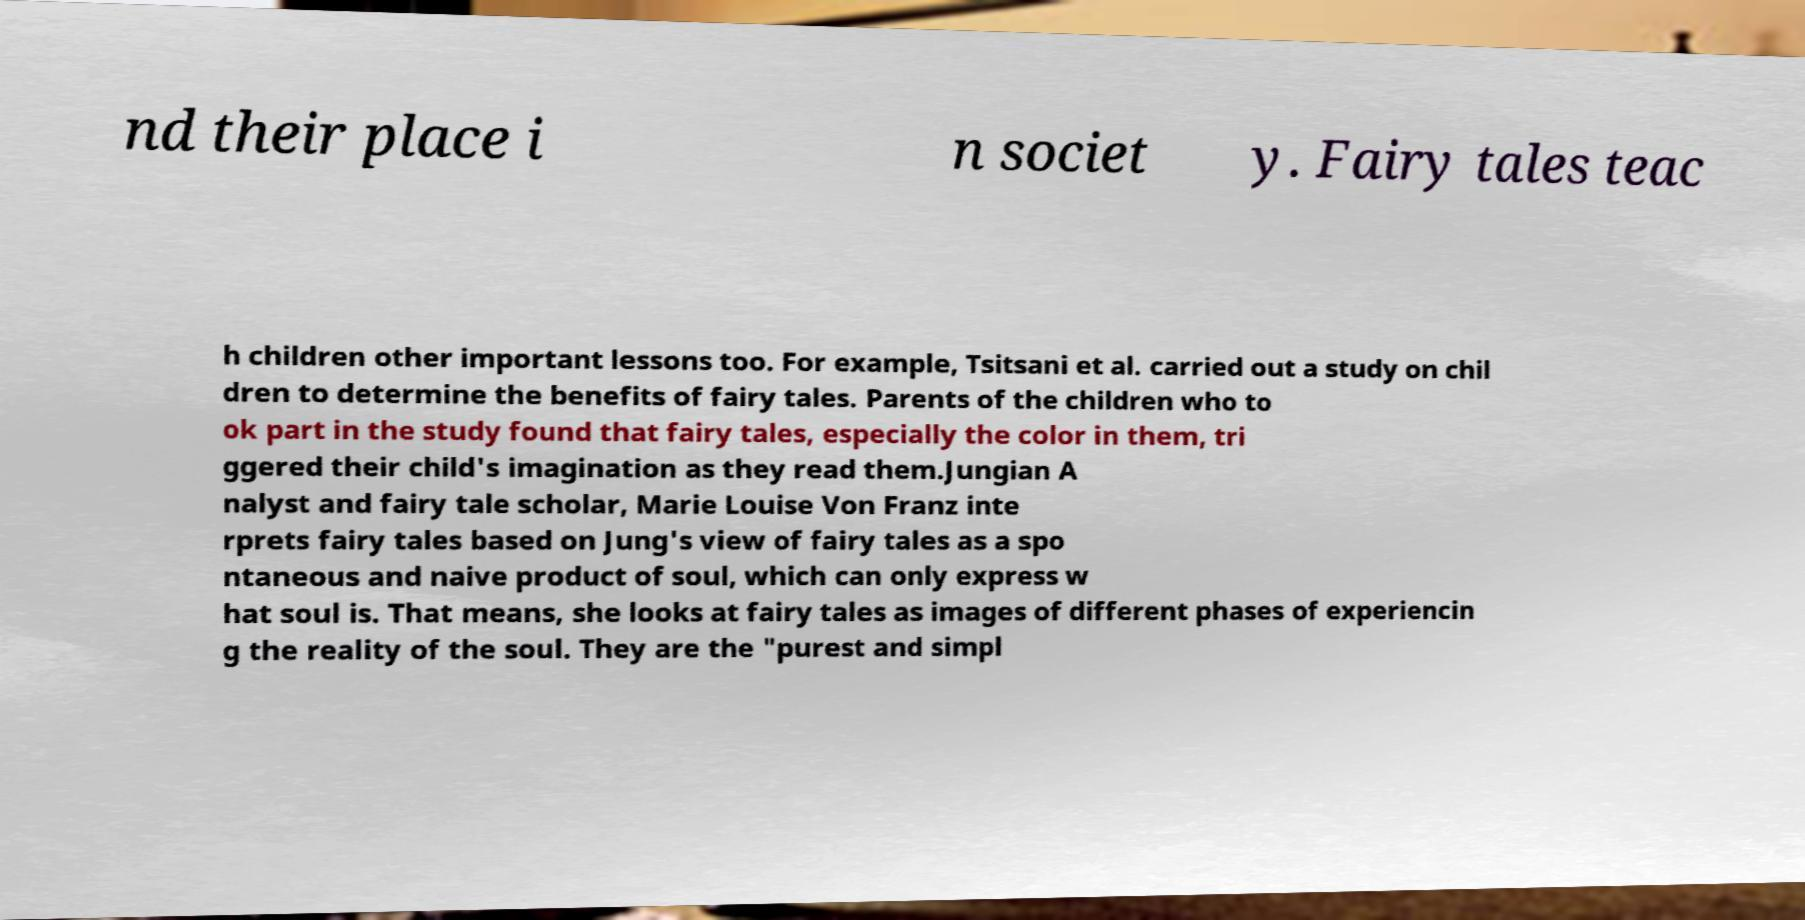I need the written content from this picture converted into text. Can you do that? nd their place i n societ y. Fairy tales teac h children other important lessons too. For example, Tsitsani et al. carried out a study on chil dren to determine the benefits of fairy tales. Parents of the children who to ok part in the study found that fairy tales, especially the color in them, tri ggered their child's imagination as they read them.Jungian A nalyst and fairy tale scholar, Marie Louise Von Franz inte rprets fairy tales based on Jung's view of fairy tales as a spo ntaneous and naive product of soul, which can only express w hat soul is. That means, she looks at fairy tales as images of different phases of experiencin g the reality of the soul. They are the "purest and simpl 